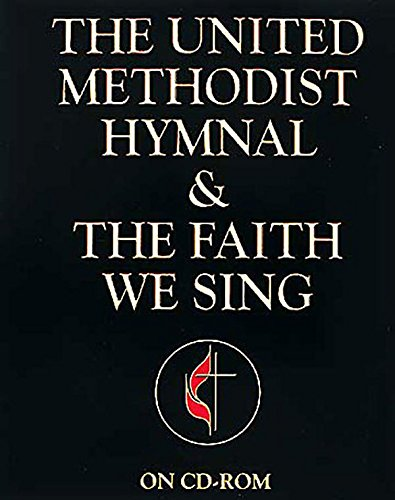What type of book is this? This is a religious book categorized under 'Christian Books & Bibles,' specifically used within the context of The United Methodist Church for hymns and liturgical purposes. 